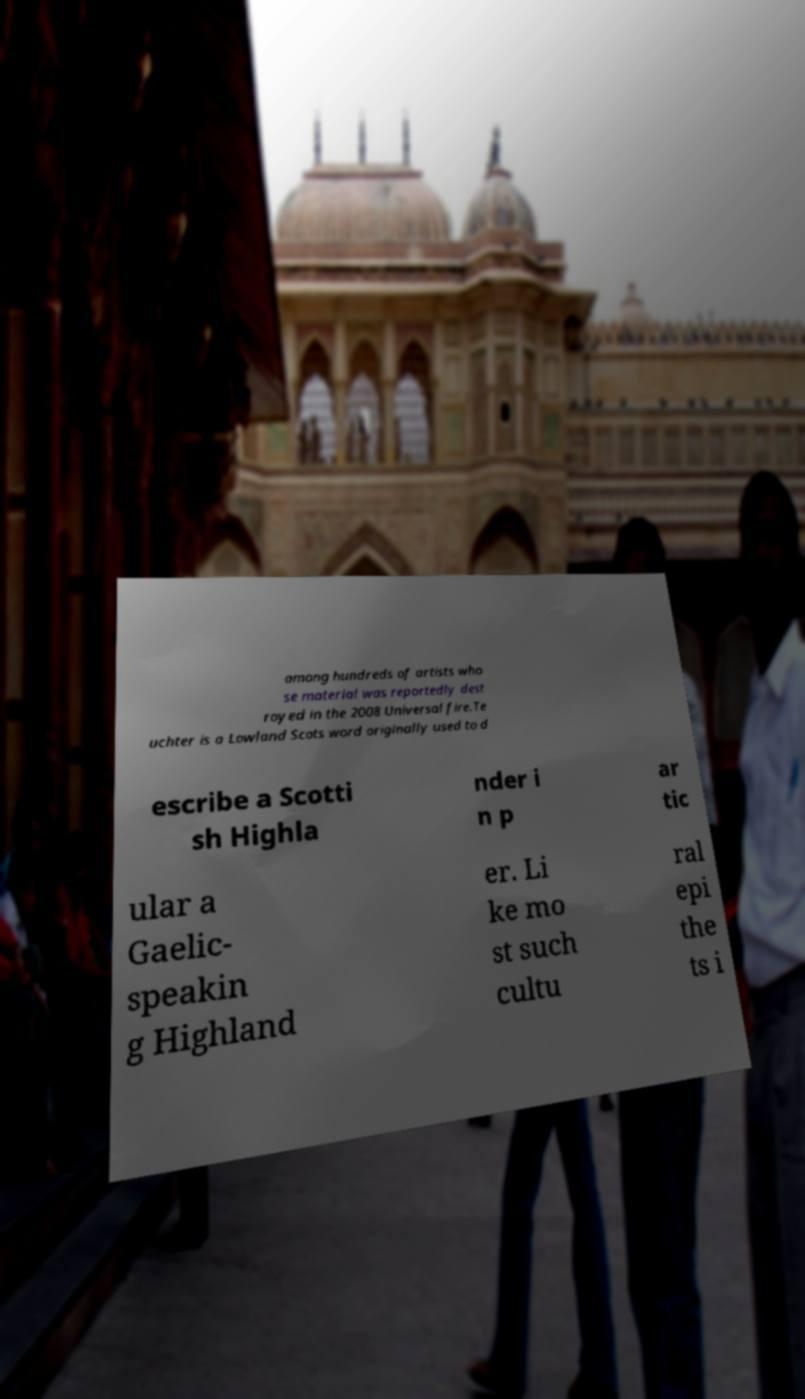Could you assist in decoding the text presented in this image and type it out clearly? among hundreds of artists who se material was reportedly dest royed in the 2008 Universal fire.Te uchter is a Lowland Scots word originally used to d escribe a Scotti sh Highla nder i n p ar tic ular a Gaelic- speakin g Highland er. Li ke mo st such cultu ral epi the ts i 